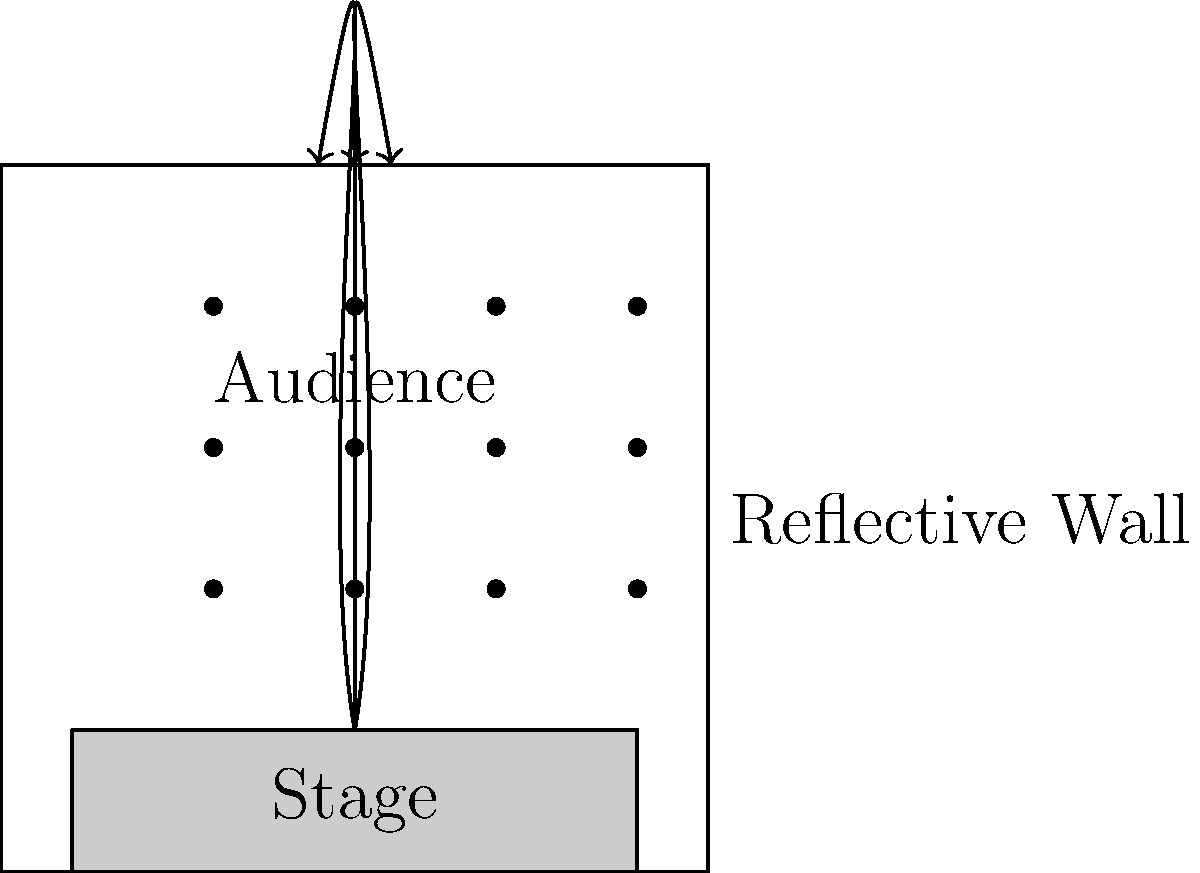In a rock concert hall, sound waves from the stage travel towards the back wall and are reflected. If the frequency of a particular sound wave is 440 Hz and the speed of sound in air is 343 m/s, what is the wavelength of this sound wave? How might the materials used in the concert hall's construction affect the sound quality experienced by the audience? To solve this problem, we'll follow these steps:

1. Calculate the wavelength of the sound wave:
   The wavelength ($\lambda$) is related to the frequency ($f$) and speed of sound ($v$) by the equation:
   $$v = f\lambda$$
   Rearranging this equation, we get:
   $$\lambda = \frac{v}{f}$$
   
   Substituting the given values:
   $$\lambda = \frac{343 \text{ m/s}}{440 \text{ Hz}} = 0.78 \text{ m}$$

2. Effect of materials on sound quality:
   a) Reflective surfaces (e.g., concrete walls, hard floors):
      - Reflect sound waves, increasing overall volume
      - Can create echoes or reverberations
      - May cause sound distortion if reflections are too strong

   b) Absorptive materials (e.g., acoustic panels, carpets, curtains):
      - Absorb sound waves, reducing reflections and echoes
      - Help control reverberation time
      - Can improve clarity of sound, especially for speech

   c) Diffusive surfaces (e.g., irregularly shaped panels):
      - Scatter sound waves in various directions
      - Help create a more even sound distribution
      - Reduce flutter echoes between parallel surfaces

   For a rock concert, a balance of reflective and absorptive materials is ideal:
   - Some reflection is desirable for liveliness and energy
   - Too much reflection can lead to muddiness and lack of clarity
   - Strategic placement of absorptive materials can help control excessive reverberations
   - Diffusive elements can help create a more immersive sound experience

The sound engineer would need to consider these factors when setting up the sound system and potentially recommend acoustic treatments to optimize the sound quality for rock music performances.
Answer: Wavelength: 0.78 m. Materials affect sound quality through reflection, absorption, and diffusion, impacting clarity, reverberation, and overall listening experience. 